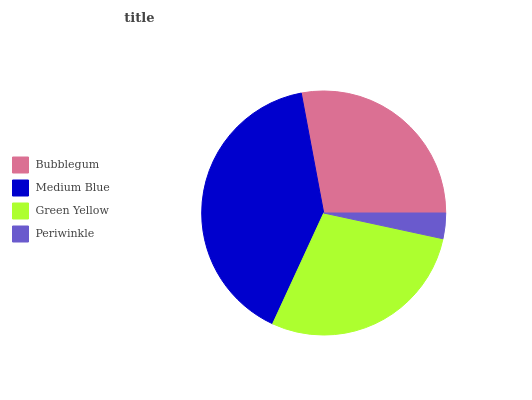Is Periwinkle the minimum?
Answer yes or no. Yes. Is Medium Blue the maximum?
Answer yes or no. Yes. Is Green Yellow the minimum?
Answer yes or no. No. Is Green Yellow the maximum?
Answer yes or no. No. Is Medium Blue greater than Green Yellow?
Answer yes or no. Yes. Is Green Yellow less than Medium Blue?
Answer yes or no. Yes. Is Green Yellow greater than Medium Blue?
Answer yes or no. No. Is Medium Blue less than Green Yellow?
Answer yes or no. No. Is Green Yellow the high median?
Answer yes or no. Yes. Is Bubblegum the low median?
Answer yes or no. Yes. Is Periwinkle the high median?
Answer yes or no. No. Is Medium Blue the low median?
Answer yes or no. No. 